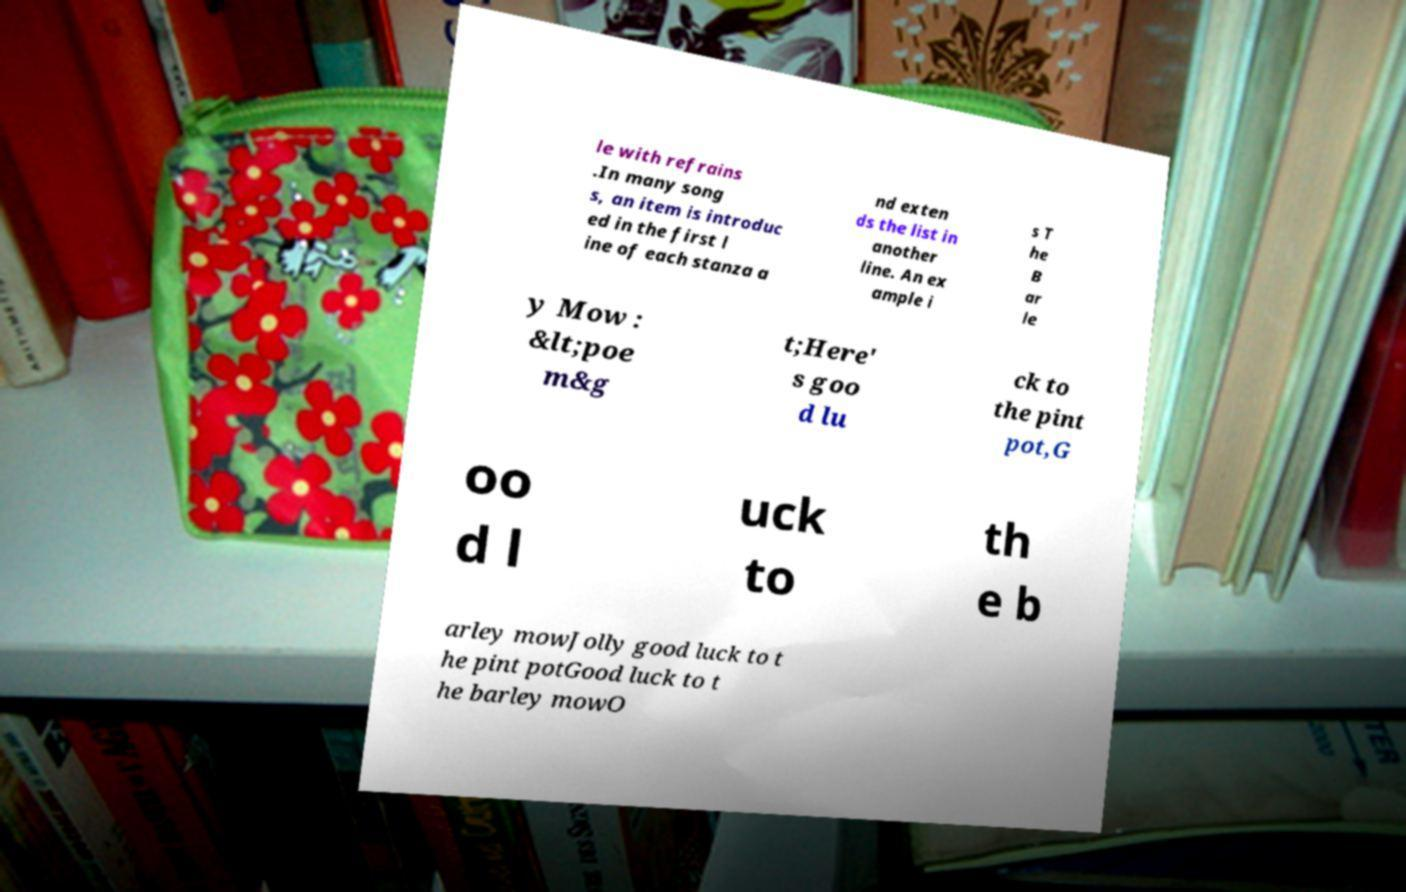I need the written content from this picture converted into text. Can you do that? le with refrains .In many song s, an item is introduc ed in the first l ine of each stanza a nd exten ds the list in another line. An ex ample i s T he B ar le y Mow : &lt;poe m&g t;Here' s goo d lu ck to the pint pot,G oo d l uck to th e b arley mowJolly good luck to t he pint potGood luck to t he barley mowO 